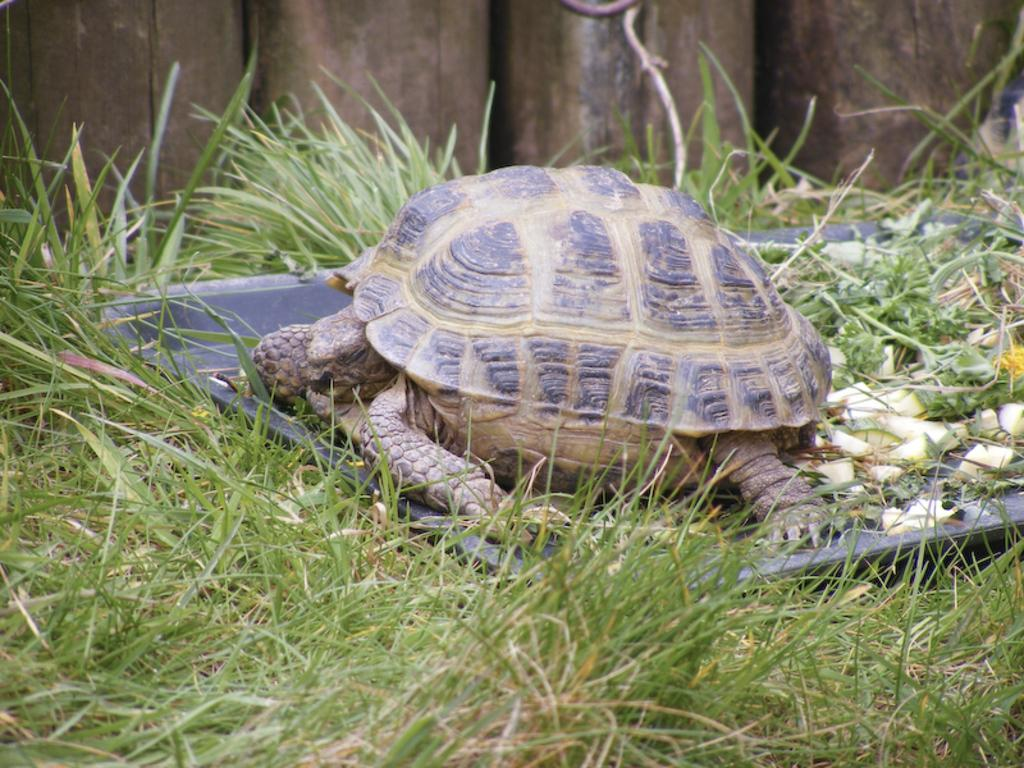What animal is in the middle of the image? There is a tortoise in the middle of the image. What type of vegetation is at the bottom of the image? There is grass at the bottom of the image. What type of stage can be seen in the background of the image? There is no stage present in the image; it features a tortoise and grass. Is there a stranger playing a guitar in the image? There is no stranger or guitar present in the image. 